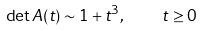<formula> <loc_0><loc_0><loc_500><loc_500>\det A ( t ) \sim 1 + t ^ { 3 } , \quad t \geq 0</formula> 